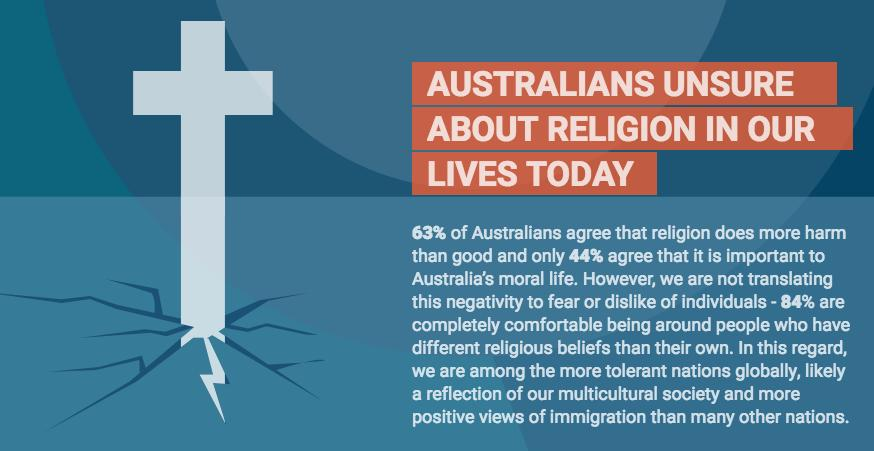Give some essential details in this illustration. According to the data, approximately 16% of Australians are not comfortable with people following different religious beliefs. According to a survey, 56% of Australians do not believe that religion is important. The color of the cross shown in the infographic is white. According to a survey conducted in Australia, 37% of the population disagrees that religion creates more problems than it provides relief. 